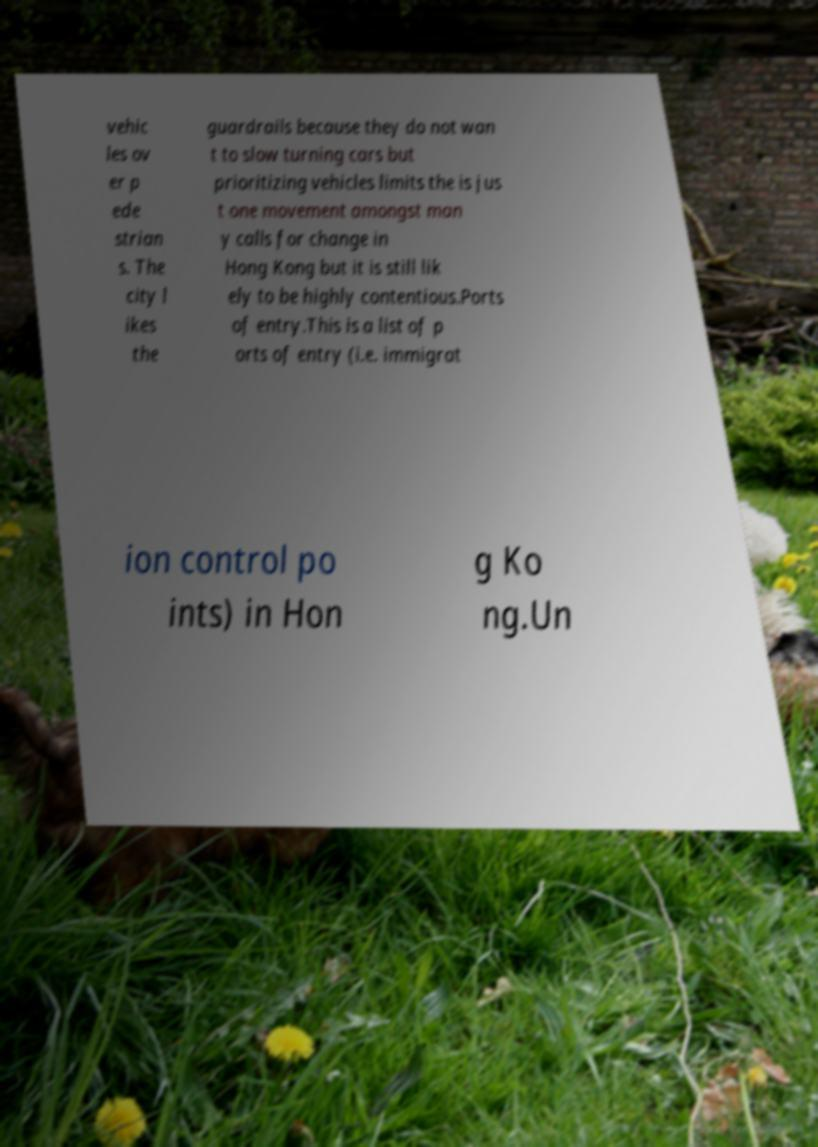Please identify and transcribe the text found in this image. vehic les ov er p ede strian s. The city l ikes the guardrails because they do not wan t to slow turning cars but prioritizing vehicles limits the is jus t one movement amongst man y calls for change in Hong Kong but it is still lik ely to be highly contentious.Ports of entry.This is a list of p orts of entry (i.e. immigrat ion control po ints) in Hon g Ko ng.Un 